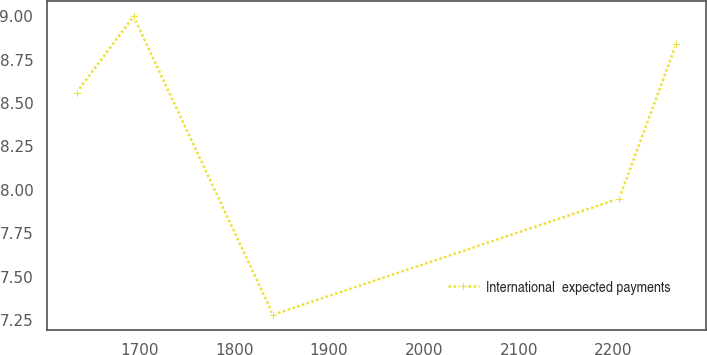<chart> <loc_0><loc_0><loc_500><loc_500><line_chart><ecel><fcel>International  expected payments<nl><fcel>1633.97<fcel>8.56<nl><fcel>1694.07<fcel>9<nl><fcel>1841.16<fcel>7.28<nl><fcel>2205.85<fcel>7.95<nl><fcel>2265.95<fcel>8.84<nl></chart> 